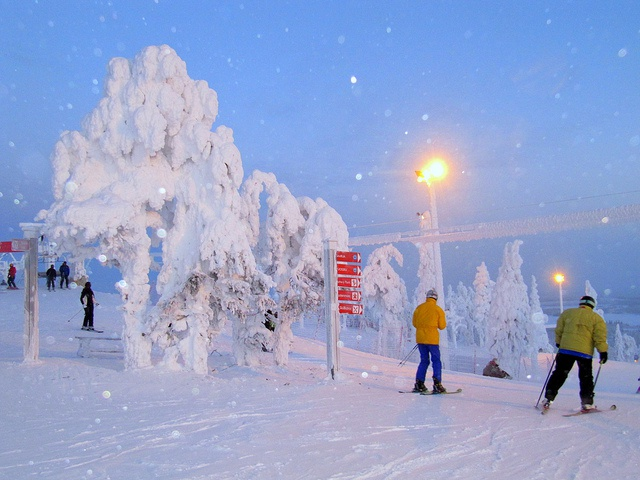Describe the objects in this image and their specific colors. I can see people in lightblue, black, olive, and gray tones, people in lightblue, olive, navy, and darkgray tones, people in lightblue, black, darkgray, gray, and navy tones, people in lightblue, gray, purple, and black tones, and people in lightblue, black, navy, gray, and darkblue tones in this image. 